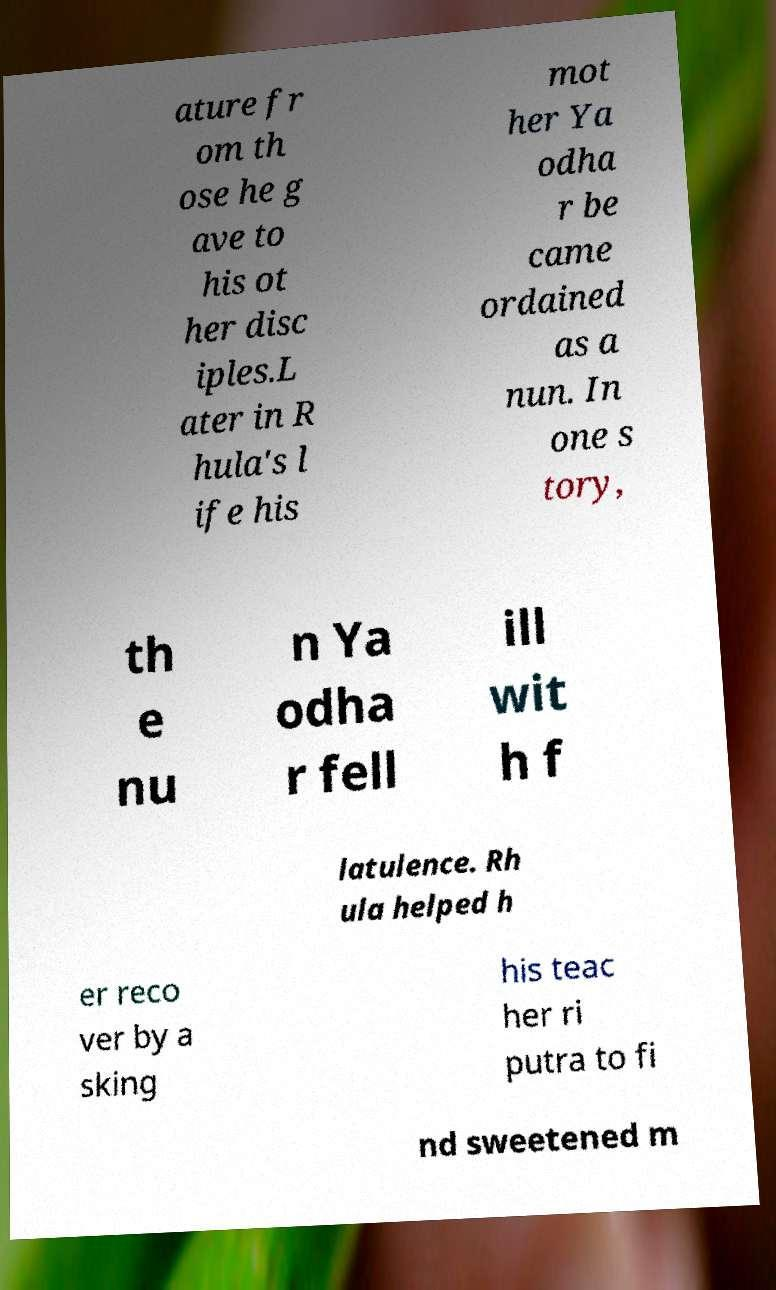Could you assist in decoding the text presented in this image and type it out clearly? ature fr om th ose he g ave to his ot her disc iples.L ater in R hula's l ife his mot her Ya odha r be came ordained as a nun. In one s tory, th e nu n Ya odha r fell ill wit h f latulence. Rh ula helped h er reco ver by a sking his teac her ri putra to fi nd sweetened m 